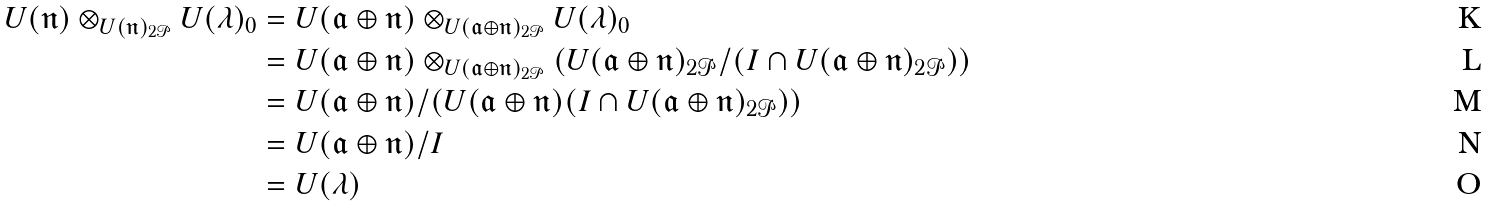Convert formula to latex. <formula><loc_0><loc_0><loc_500><loc_500>U ( \mathfrak { n } ) \otimes _ { U ( \mathfrak { n } ) _ { 2 \mathcal { P } } } U ( \lambda ) _ { 0 } & = U ( \mathfrak { a } \oplus \mathfrak { n } ) \otimes _ { U ( \mathfrak { a } \oplus \mathfrak { n } ) _ { 2 \mathcal { P } } } U ( \lambda ) _ { 0 } \\ & = U ( \mathfrak { a } \oplus \mathfrak { n } ) \otimes _ { U ( \mathfrak { a } \oplus \mathfrak { n } ) _ { 2 \mathcal { P } } } ( U ( \mathfrak { a } \oplus \mathfrak { n } ) _ { 2 \mathcal { P } } / ( I \cap U ( \mathfrak { a } \oplus \mathfrak { n } ) _ { 2 \mathcal { P } } ) ) \\ & = U ( \mathfrak { a } \oplus \mathfrak { n } ) / ( U ( \mathfrak { a } \oplus \mathfrak { n } ) ( I \cap U ( \mathfrak { a } \oplus \mathfrak { n } ) _ { 2 \mathcal { P } } ) ) \\ & = U ( \mathfrak { a } \oplus \mathfrak { n } ) / I \\ & = U ( \lambda )</formula> 